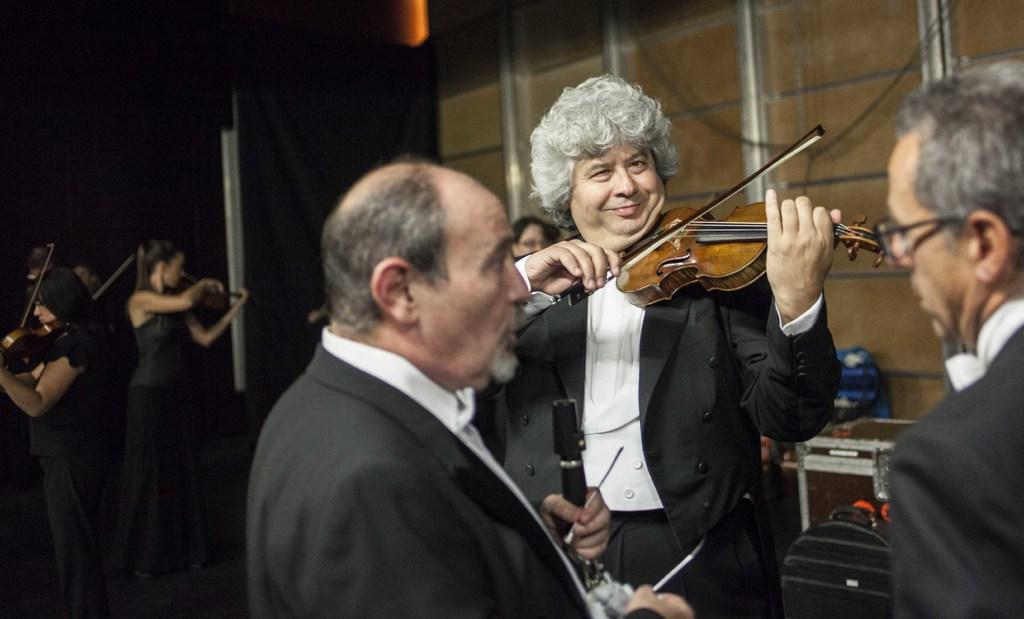What are the persons in the image doing? The persons in the image are standing and playing a violin. Can you describe the attire of one of the persons? One person is wearing a black suit. What object can be seen in the image besides the persons and the violin? There is a box in the image. What type of wheel can be seen in the image? There is no wheel present in the image. Is the violin being played in space in the image? The image does not depict the violin being played in space; it is being played on a regular surface. 